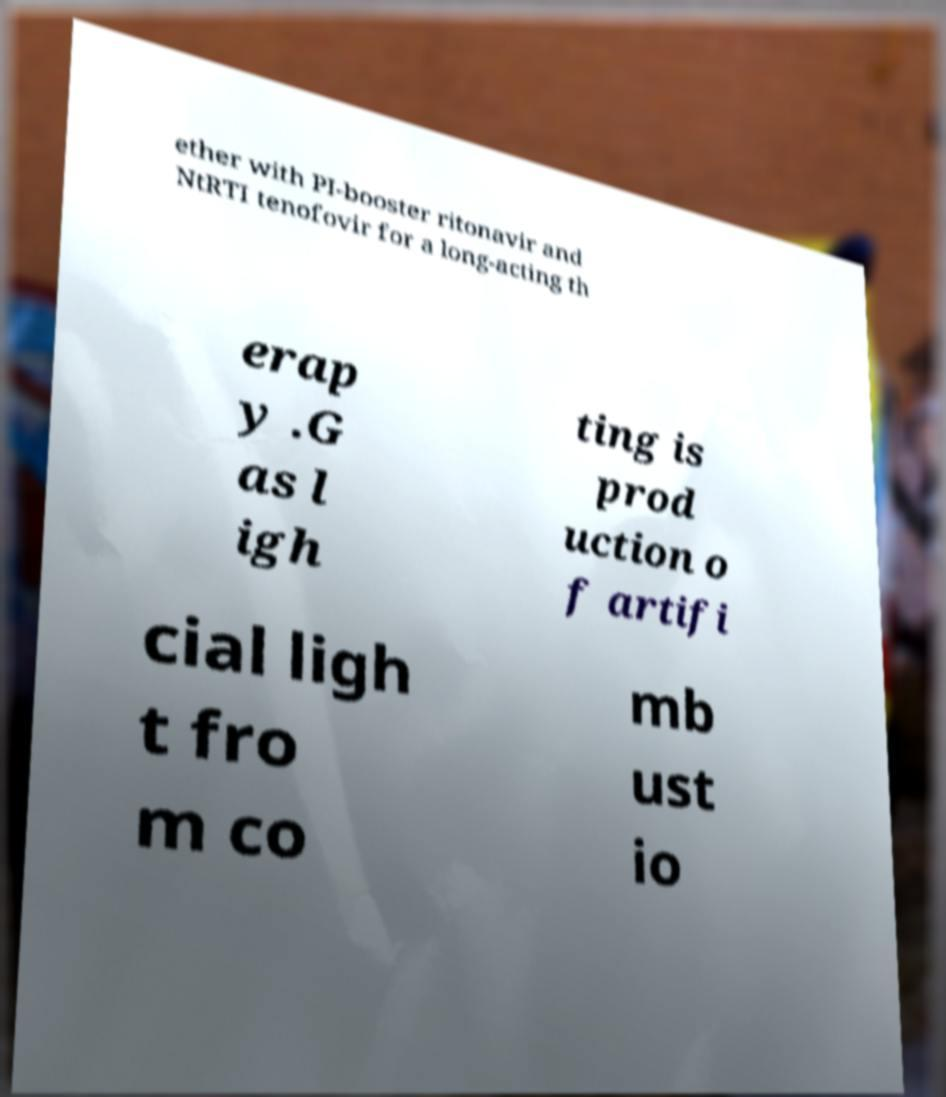Can you read and provide the text displayed in the image?This photo seems to have some interesting text. Can you extract and type it out for me? ether with PI-booster ritonavir and NtRTI tenofovir for a long-acting th erap y .G as l igh ting is prod uction o f artifi cial ligh t fro m co mb ust io 